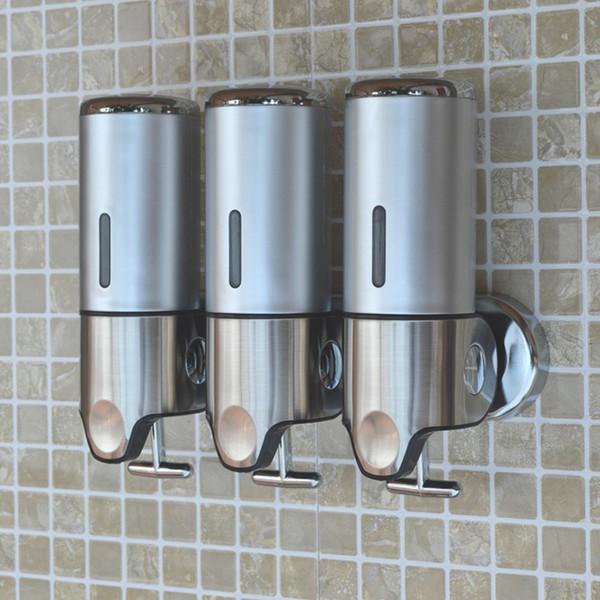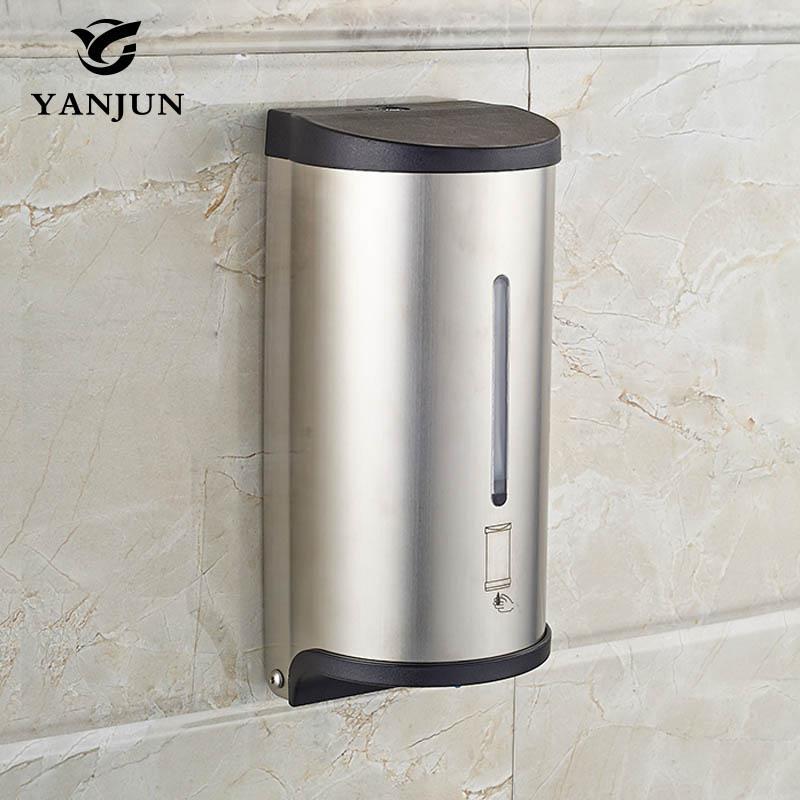The first image is the image on the left, the second image is the image on the right. Examine the images to the left and right. Is the description "An image shows at least two side-by-side dispensers that feature a chrome T-shaped bar underneath." accurate? Answer yes or no. Yes. The first image is the image on the left, the second image is the image on the right. Analyze the images presented: Is the assertion "There are four soap dispensers in total." valid? Answer yes or no. Yes. 